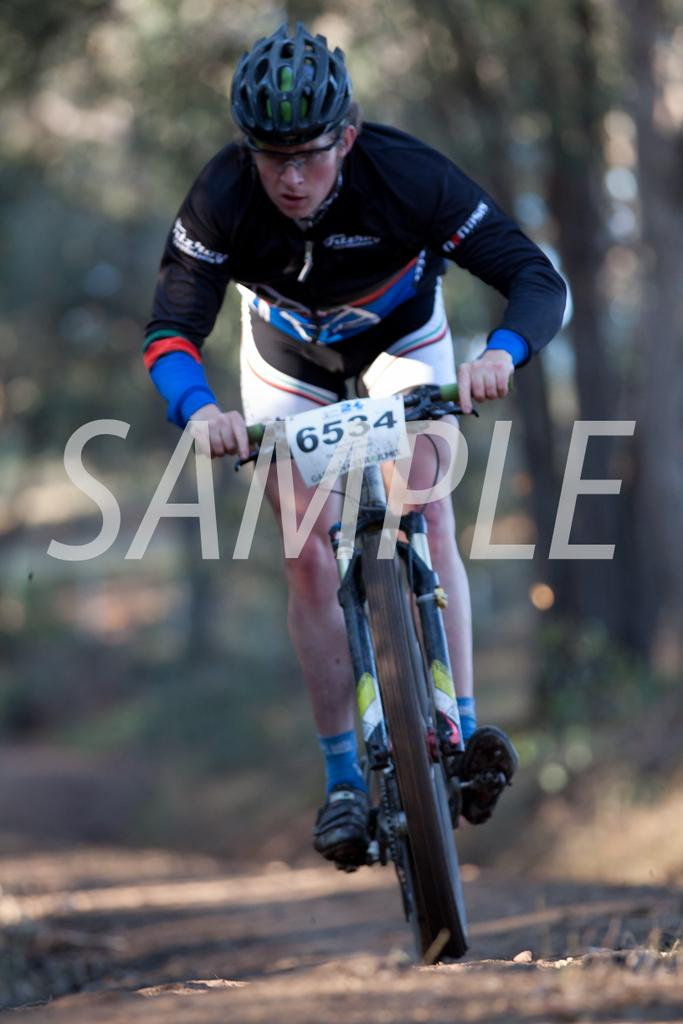Who is the main subject in the image? There is a man in the image. What type of clothing is the man wearing? The man is wearing a sports dress. What protective gear is the man wearing? The man is wearing a helmet. What activity is the man engaged in? The man is riding a bicycle. What can be seen in the background of the image? There are trees visible in the background of the image. Is the man's uncle riding a goat in the image? There is no goat or uncle present in the image. The man is riding a bicycle, not a goat. 